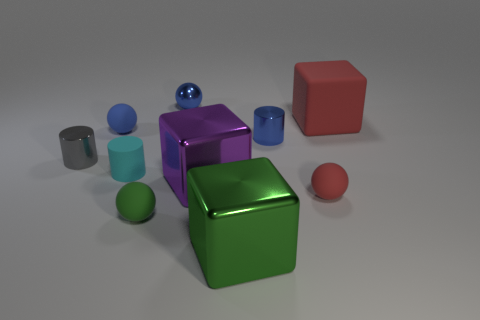How many red objects are either small balls or tiny rubber spheres?
Offer a terse response. 1. What is the color of the large cube that is made of the same material as the big purple object?
Offer a very short reply. Green. There is a big matte cube; does it have the same color as the tiny rubber sphere that is behind the small matte cylinder?
Provide a short and direct response. No. The tiny matte object that is on the left side of the small red rubber sphere and in front of the large purple shiny object is what color?
Offer a terse response. Green. How many large red objects are in front of the large green cube?
Offer a very short reply. 0. How many objects are either small cyan objects or cubes that are behind the gray metal cylinder?
Offer a very short reply. 2. Is there a big shiny block to the left of the gray metal cylinder that is left of the large red object?
Offer a terse response. No. There is a large object that is behind the tiny cyan matte object; what color is it?
Ensure brevity in your answer.  Red. Are there an equal number of small gray cylinders on the right side of the large purple shiny block and large blue metallic things?
Your answer should be very brief. Yes. What is the shape of the thing that is behind the small gray object and on the left side of the shiny sphere?
Give a very brief answer. Sphere. 